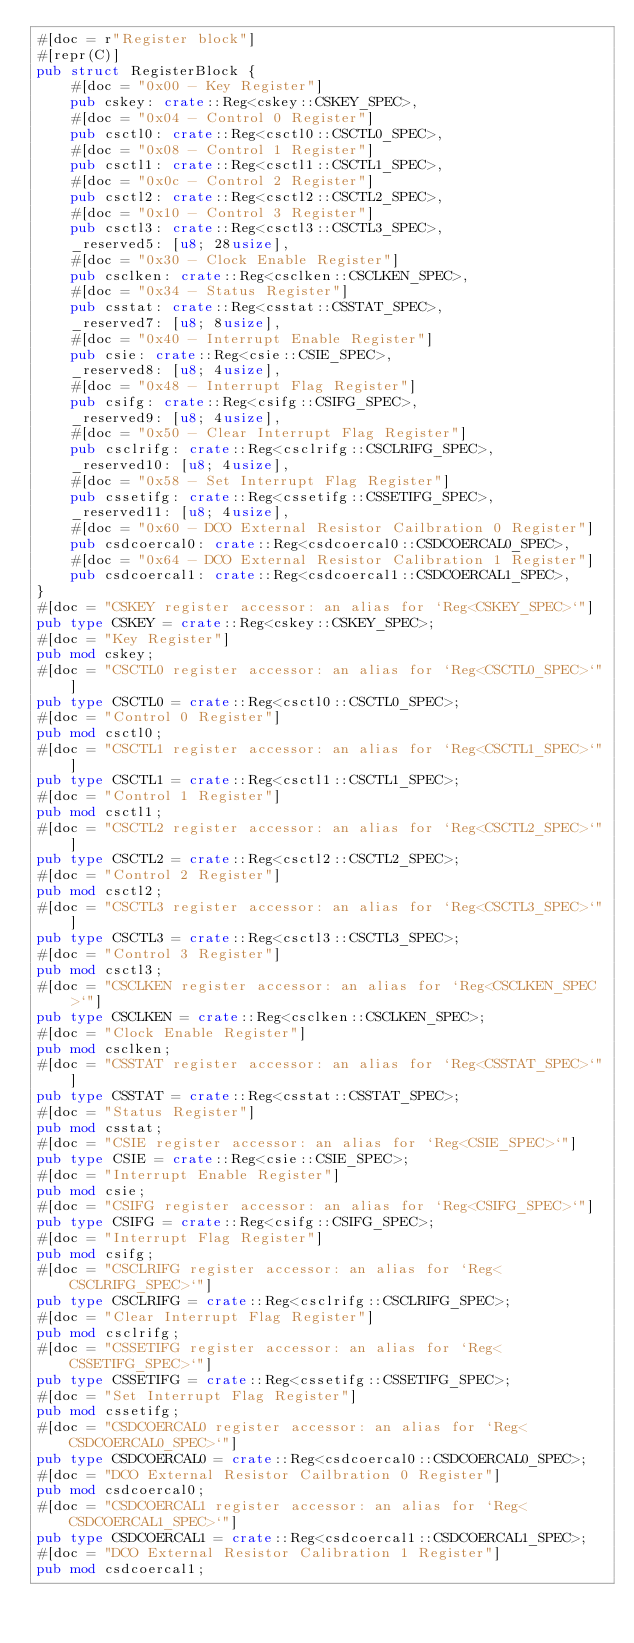Convert code to text. <code><loc_0><loc_0><loc_500><loc_500><_Rust_>#[doc = r"Register block"]
#[repr(C)]
pub struct RegisterBlock {
    #[doc = "0x00 - Key Register"]
    pub cskey: crate::Reg<cskey::CSKEY_SPEC>,
    #[doc = "0x04 - Control 0 Register"]
    pub csctl0: crate::Reg<csctl0::CSCTL0_SPEC>,
    #[doc = "0x08 - Control 1 Register"]
    pub csctl1: crate::Reg<csctl1::CSCTL1_SPEC>,
    #[doc = "0x0c - Control 2 Register"]
    pub csctl2: crate::Reg<csctl2::CSCTL2_SPEC>,
    #[doc = "0x10 - Control 3 Register"]
    pub csctl3: crate::Reg<csctl3::CSCTL3_SPEC>,
    _reserved5: [u8; 28usize],
    #[doc = "0x30 - Clock Enable Register"]
    pub csclken: crate::Reg<csclken::CSCLKEN_SPEC>,
    #[doc = "0x34 - Status Register"]
    pub csstat: crate::Reg<csstat::CSSTAT_SPEC>,
    _reserved7: [u8; 8usize],
    #[doc = "0x40 - Interrupt Enable Register"]
    pub csie: crate::Reg<csie::CSIE_SPEC>,
    _reserved8: [u8; 4usize],
    #[doc = "0x48 - Interrupt Flag Register"]
    pub csifg: crate::Reg<csifg::CSIFG_SPEC>,
    _reserved9: [u8; 4usize],
    #[doc = "0x50 - Clear Interrupt Flag Register"]
    pub csclrifg: crate::Reg<csclrifg::CSCLRIFG_SPEC>,
    _reserved10: [u8; 4usize],
    #[doc = "0x58 - Set Interrupt Flag Register"]
    pub cssetifg: crate::Reg<cssetifg::CSSETIFG_SPEC>,
    _reserved11: [u8; 4usize],
    #[doc = "0x60 - DCO External Resistor Cailbration 0 Register"]
    pub csdcoercal0: crate::Reg<csdcoercal0::CSDCOERCAL0_SPEC>,
    #[doc = "0x64 - DCO External Resistor Calibration 1 Register"]
    pub csdcoercal1: crate::Reg<csdcoercal1::CSDCOERCAL1_SPEC>,
}
#[doc = "CSKEY register accessor: an alias for `Reg<CSKEY_SPEC>`"]
pub type CSKEY = crate::Reg<cskey::CSKEY_SPEC>;
#[doc = "Key Register"]
pub mod cskey;
#[doc = "CSCTL0 register accessor: an alias for `Reg<CSCTL0_SPEC>`"]
pub type CSCTL0 = crate::Reg<csctl0::CSCTL0_SPEC>;
#[doc = "Control 0 Register"]
pub mod csctl0;
#[doc = "CSCTL1 register accessor: an alias for `Reg<CSCTL1_SPEC>`"]
pub type CSCTL1 = crate::Reg<csctl1::CSCTL1_SPEC>;
#[doc = "Control 1 Register"]
pub mod csctl1;
#[doc = "CSCTL2 register accessor: an alias for `Reg<CSCTL2_SPEC>`"]
pub type CSCTL2 = crate::Reg<csctl2::CSCTL2_SPEC>;
#[doc = "Control 2 Register"]
pub mod csctl2;
#[doc = "CSCTL3 register accessor: an alias for `Reg<CSCTL3_SPEC>`"]
pub type CSCTL3 = crate::Reg<csctl3::CSCTL3_SPEC>;
#[doc = "Control 3 Register"]
pub mod csctl3;
#[doc = "CSCLKEN register accessor: an alias for `Reg<CSCLKEN_SPEC>`"]
pub type CSCLKEN = crate::Reg<csclken::CSCLKEN_SPEC>;
#[doc = "Clock Enable Register"]
pub mod csclken;
#[doc = "CSSTAT register accessor: an alias for `Reg<CSSTAT_SPEC>`"]
pub type CSSTAT = crate::Reg<csstat::CSSTAT_SPEC>;
#[doc = "Status Register"]
pub mod csstat;
#[doc = "CSIE register accessor: an alias for `Reg<CSIE_SPEC>`"]
pub type CSIE = crate::Reg<csie::CSIE_SPEC>;
#[doc = "Interrupt Enable Register"]
pub mod csie;
#[doc = "CSIFG register accessor: an alias for `Reg<CSIFG_SPEC>`"]
pub type CSIFG = crate::Reg<csifg::CSIFG_SPEC>;
#[doc = "Interrupt Flag Register"]
pub mod csifg;
#[doc = "CSCLRIFG register accessor: an alias for `Reg<CSCLRIFG_SPEC>`"]
pub type CSCLRIFG = crate::Reg<csclrifg::CSCLRIFG_SPEC>;
#[doc = "Clear Interrupt Flag Register"]
pub mod csclrifg;
#[doc = "CSSETIFG register accessor: an alias for `Reg<CSSETIFG_SPEC>`"]
pub type CSSETIFG = crate::Reg<cssetifg::CSSETIFG_SPEC>;
#[doc = "Set Interrupt Flag Register"]
pub mod cssetifg;
#[doc = "CSDCOERCAL0 register accessor: an alias for `Reg<CSDCOERCAL0_SPEC>`"]
pub type CSDCOERCAL0 = crate::Reg<csdcoercal0::CSDCOERCAL0_SPEC>;
#[doc = "DCO External Resistor Cailbration 0 Register"]
pub mod csdcoercal0;
#[doc = "CSDCOERCAL1 register accessor: an alias for `Reg<CSDCOERCAL1_SPEC>`"]
pub type CSDCOERCAL1 = crate::Reg<csdcoercal1::CSDCOERCAL1_SPEC>;
#[doc = "DCO External Resistor Calibration 1 Register"]
pub mod csdcoercal1;
</code> 